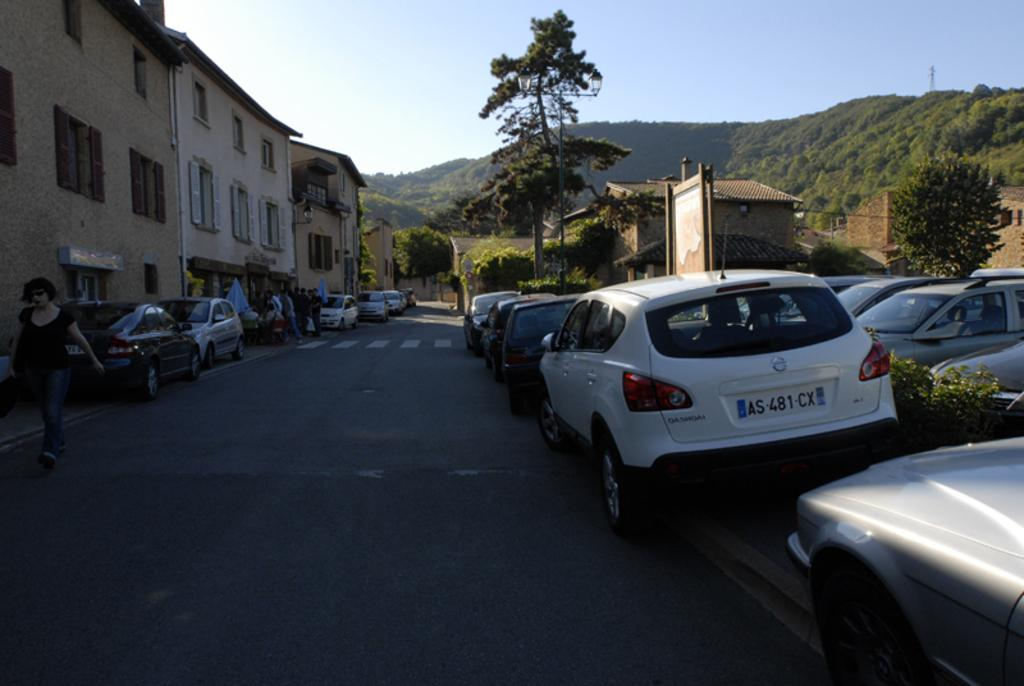What type of vehicles can be seen on the road in the image? There are cars on the road in the image. Can you describe the people in the image? There are people in the image. What structures are visible in the image? There are buildings in the image. What type of natural elements can be seen in the image? There are trees and a mountain in the image. What object is present in the image that might be used for displaying information? There is a board in the image. What part of the natural environment is visible in the image? The sky is visible in the image. Are there any people reading in bed in the image? There is no mention of people reading or beds in the image; it features cars on the road, people, buildings, trees, a mountain, a board, and the sky. How many trees are there in the image? The number of trees in the image is not specified, but there are trees present. 